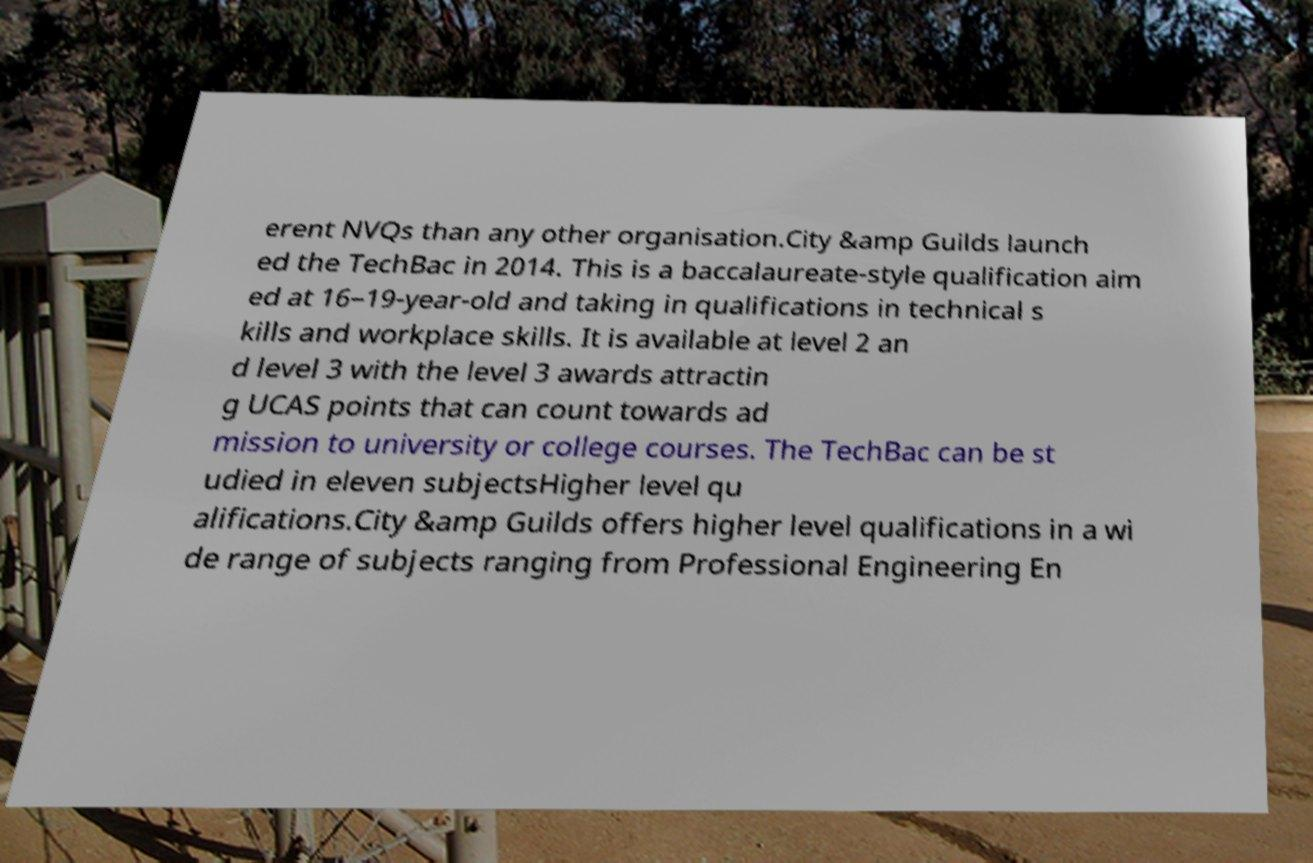For documentation purposes, I need the text within this image transcribed. Could you provide that? erent NVQs than any other organisation.City &amp Guilds launch ed the TechBac in 2014. This is a baccalaureate-style qualification aim ed at 16–19-year-old and taking in qualifications in technical s kills and workplace skills. It is available at level 2 an d level 3 with the level 3 awards attractin g UCAS points that can count towards ad mission to university or college courses. The TechBac can be st udied in eleven subjectsHigher level qu alifications.City &amp Guilds offers higher level qualifications in a wi de range of subjects ranging from Professional Engineering En 